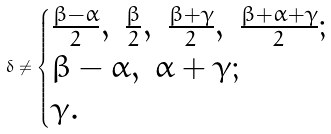<formula> <loc_0><loc_0><loc_500><loc_500>\delta \neq \begin{cases} \frac { \beta - \alpha } { 2 } , \ \frac { \beta } { 2 } , \ \frac { \beta + \gamma } { 2 } , \ \frac { \beta + \alpha + \gamma } { 2 } ; \\ \beta - \alpha , \ \alpha + \gamma ; \\ \gamma . \end{cases}</formula> 